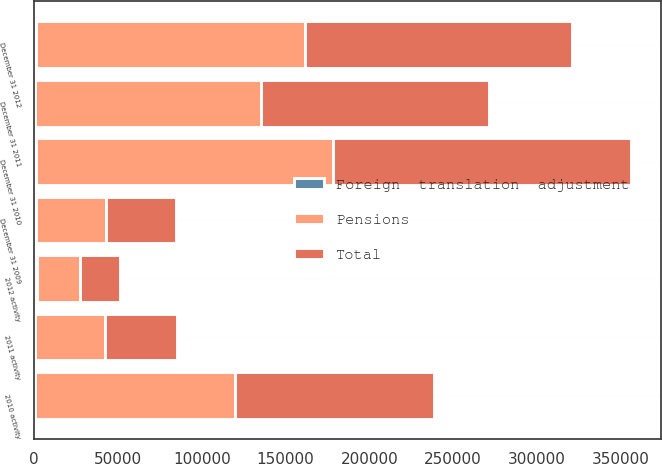Convert chart. <chart><loc_0><loc_0><loc_500><loc_500><stacked_bar_chart><ecel><fcel>December 31 2009<fcel>2010 activity<fcel>December 31 2010<fcel>2011 activity<fcel>December 31 2011<fcel>2012 activity<fcel>December 31 2012<nl><fcel>Pensions<fcel>42006<fcel>119200<fcel>176982<fcel>42006<fcel>134976<fcel>25685<fcel>160661<nl><fcel>Foreign  translation  adjustment<fcel>735<fcel>380<fcel>1115<fcel>452<fcel>663<fcel>1591<fcel>928<nl><fcel>Total<fcel>42006<fcel>118820<fcel>178097<fcel>42458<fcel>135639<fcel>24094<fcel>159733<nl></chart> 